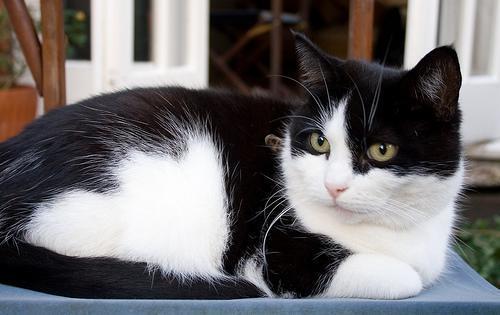How many of the cats eyes are blue?
Give a very brief answer. 0. 